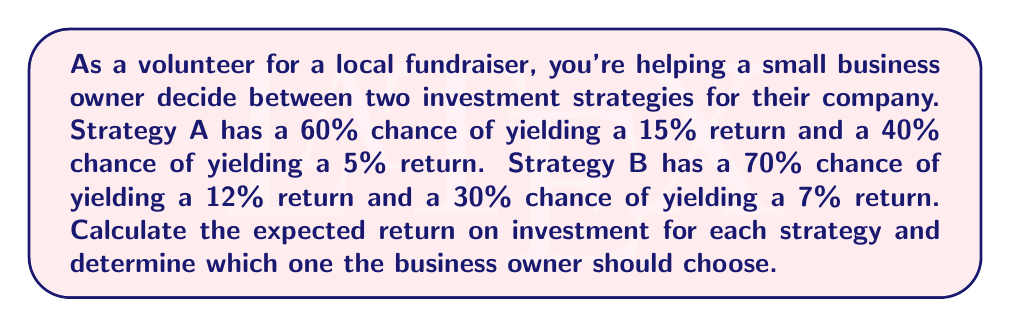Show me your answer to this math problem. Let's approach this problem using probability theory and decision trees:

1. Strategy A:
   - 60% chance of 15% return
   - 40% chance of 5% return

   Expected Return A = $$(0.60 \times 15\%) + (0.40 \times 5\%)$$
                     = $$9\% + 2\%$$
                     = $$11\%$$

2. Strategy B:
   - 70% chance of 12% return
   - 30% chance of 7% return

   Expected Return B = $$(0.70 \times 12\%) + (0.30 \times 7\%)$$
                     = $$8.4\% + 2.1\%$$
                     = $$10.5\%$$

3. Compare the expected returns:
   Strategy A: 11%
   Strategy B: 10.5%

4. Decision:
   Since Strategy A has a higher expected return (11% > 10.5%), the business owner should choose Strategy A.

[asy]
import geometry;

// Define points
pair A = (0,0);
pair B1 = (100,50);
pair B2 = (100,-50);
pair C1 = (200,75);
pair C2 = (200,25);
pair C3 = (200,-25);
pair C4 = (200,-75);

// Draw lines
draw(A--B1--C1);
draw(B1--C2);
draw(A--B2--C3);
draw(B2--C4);

// Add labels
label("Start", A, W);
label("Strategy A", B1, W);
label("Strategy B", B2, W);
label("15% (60%)", (B1+C1)/2, N);
label("5% (40%)", (B1+C2)/2, S);
label("12% (70%)", (B2+C3)/2, N);
label("7% (30%)", (B2+C4)/2, S);

// Add expected values
label("E(A) = 11%", (150,50), E);
label("E(B) = 10.5%", (150,-50), E);
[/asy]
Answer: Strategy A with 11% expected return. 